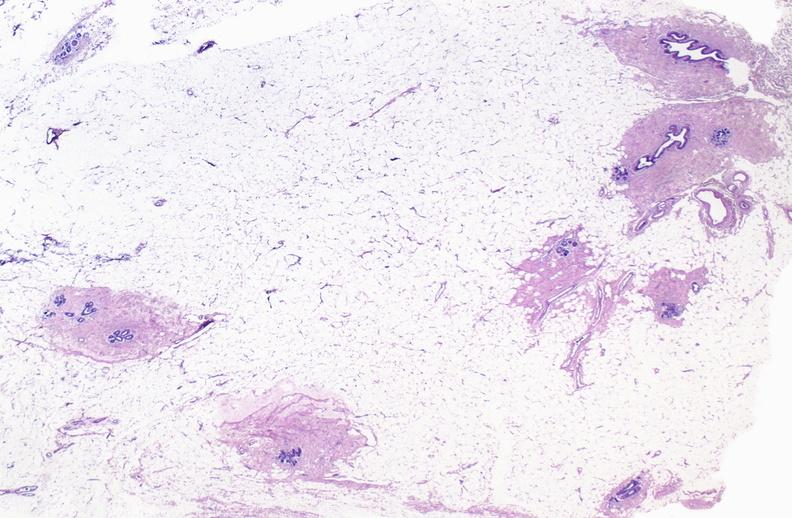does this image show normal breast?
Answer the question using a single word or phrase. Yes 